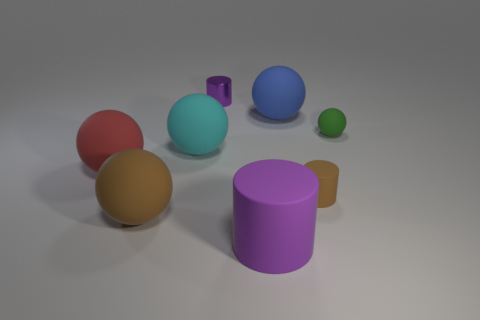There is a red rubber object that is the same shape as the green rubber object; what is its size?
Provide a succinct answer. Large. There is a matte ball that is the same color as the tiny rubber cylinder; what size is it?
Make the answer very short. Large. There is a cylinder that is the same size as the red matte object; what is its color?
Your answer should be compact. Purple. How many blue things have the same shape as the tiny green rubber thing?
Ensure brevity in your answer.  1. Are the small cylinder that is in front of the small purple thing and the brown sphere made of the same material?
Offer a very short reply. Yes. What number of balls are tiny gray rubber things or blue things?
Keep it short and to the point. 1. The big brown object that is in front of the purple object left of the purple object in front of the big red sphere is what shape?
Your response must be concise. Sphere. The large rubber thing that is the same color as the metallic cylinder is what shape?
Provide a short and direct response. Cylinder. How many red rubber balls are the same size as the cyan sphere?
Your response must be concise. 1. Is there a cyan sphere that is in front of the object in front of the big brown thing?
Offer a very short reply. No. 